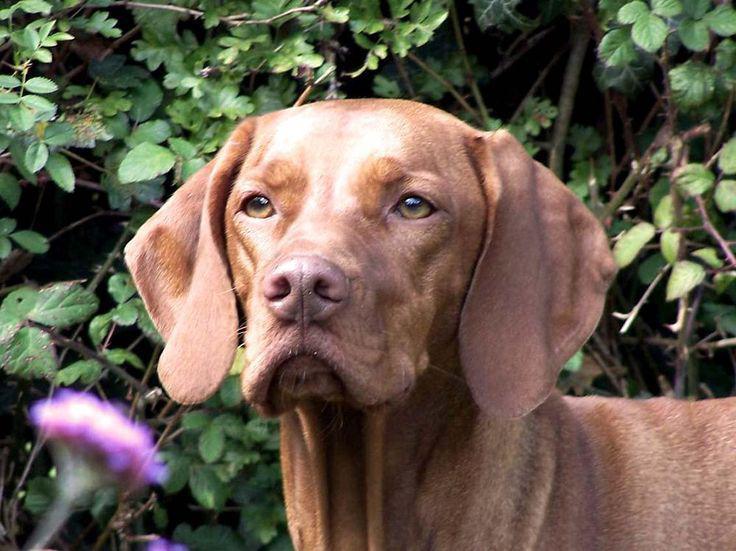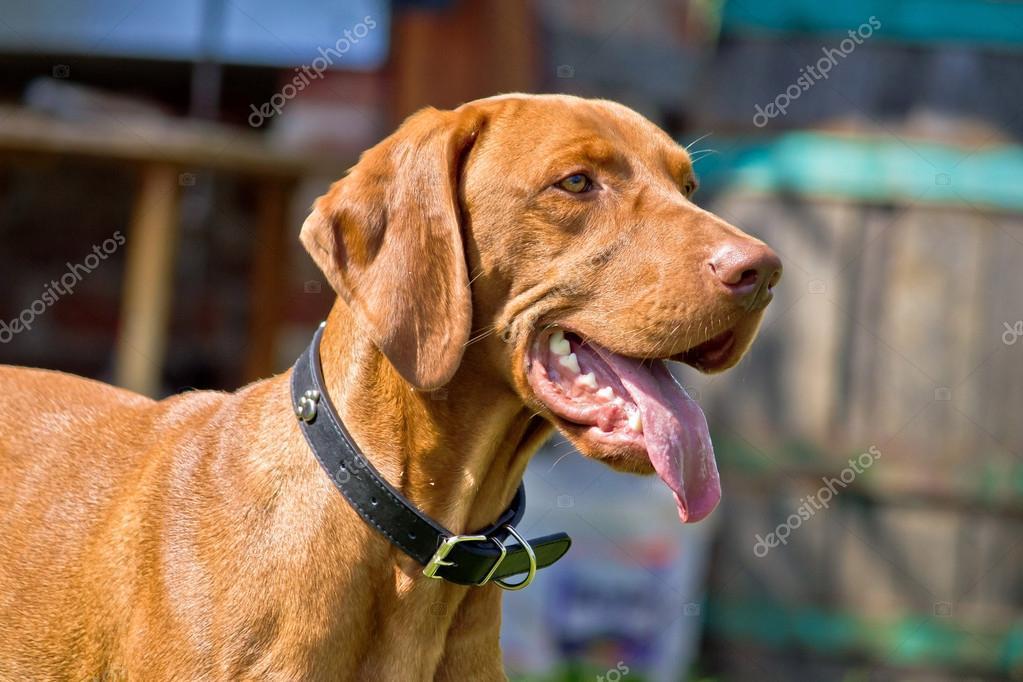The first image is the image on the left, the second image is the image on the right. Given the left and right images, does the statement "One of the images shows a dog standing in green grass with a leg up in the air." hold true? Answer yes or no. No. The first image is the image on the left, the second image is the image on the right. For the images displayed, is the sentence "One image shows a standing dog holding a long tan item in its mouth." factually correct? Answer yes or no. No. 